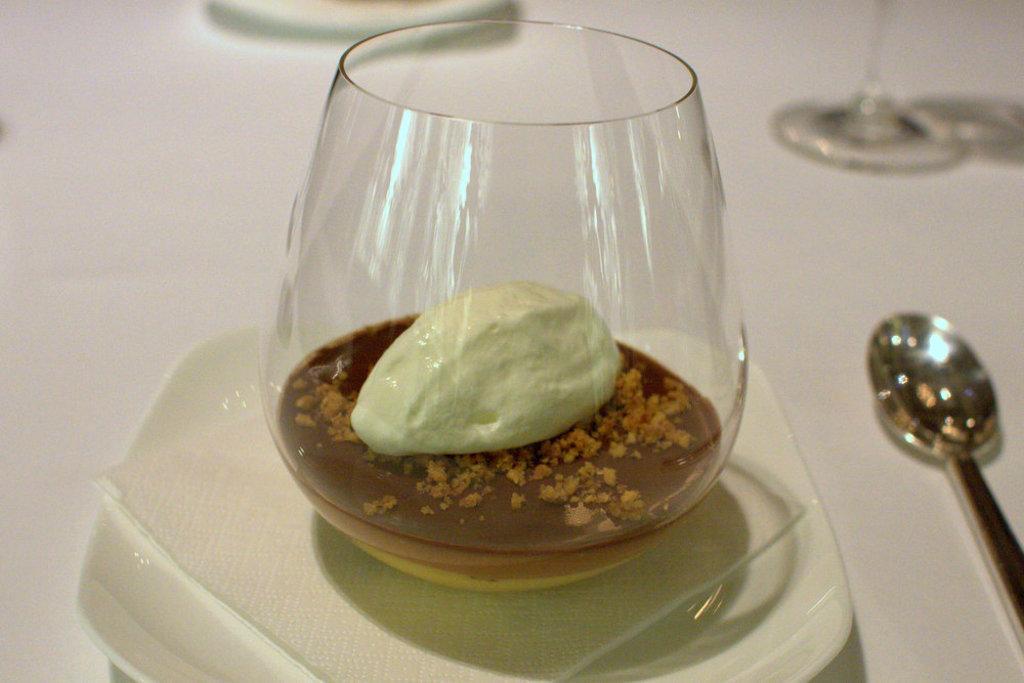Could you give a brief overview of what you see in this image? There is a white surface. On that there is a plate and a spoon. On the plate there is a glass with food item. 